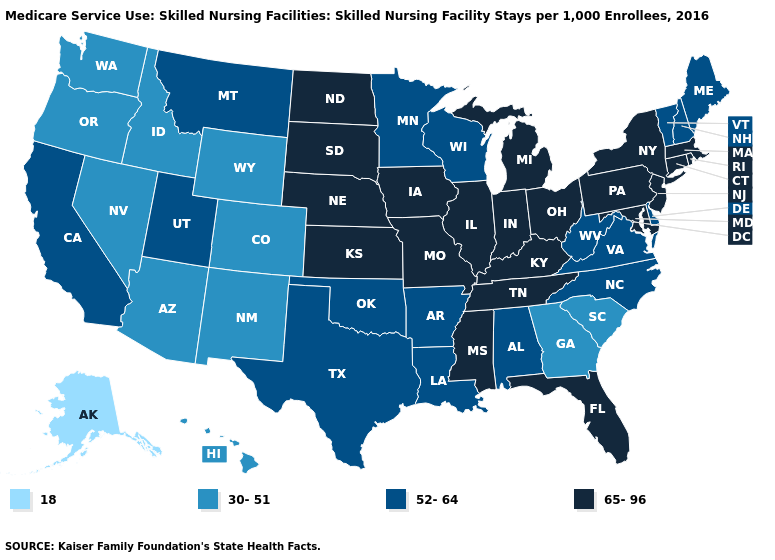Does Colorado have the highest value in the USA?
Write a very short answer. No. What is the value of Arizona?
Concise answer only. 30-51. Does the map have missing data?
Keep it brief. No. What is the lowest value in states that border Kansas?
Answer briefly. 30-51. Does Delaware have the same value as Maine?
Keep it brief. Yes. What is the value of Texas?
Short answer required. 52-64. Name the states that have a value in the range 30-51?
Give a very brief answer. Arizona, Colorado, Georgia, Hawaii, Idaho, Nevada, New Mexico, Oregon, South Carolina, Washington, Wyoming. Among the states that border Massachusetts , does Rhode Island have the lowest value?
Concise answer only. No. Does South Carolina have a higher value than Florida?
Give a very brief answer. No. Name the states that have a value in the range 18?
Write a very short answer. Alaska. Among the states that border Arkansas , does Mississippi have the lowest value?
Quick response, please. No. Does Alaska have the lowest value in the USA?
Short answer required. Yes. Does Pennsylvania have a higher value than Illinois?
Short answer required. No. Name the states that have a value in the range 18?
Write a very short answer. Alaska. Does Arizona have a lower value than Nevada?
Keep it brief. No. 